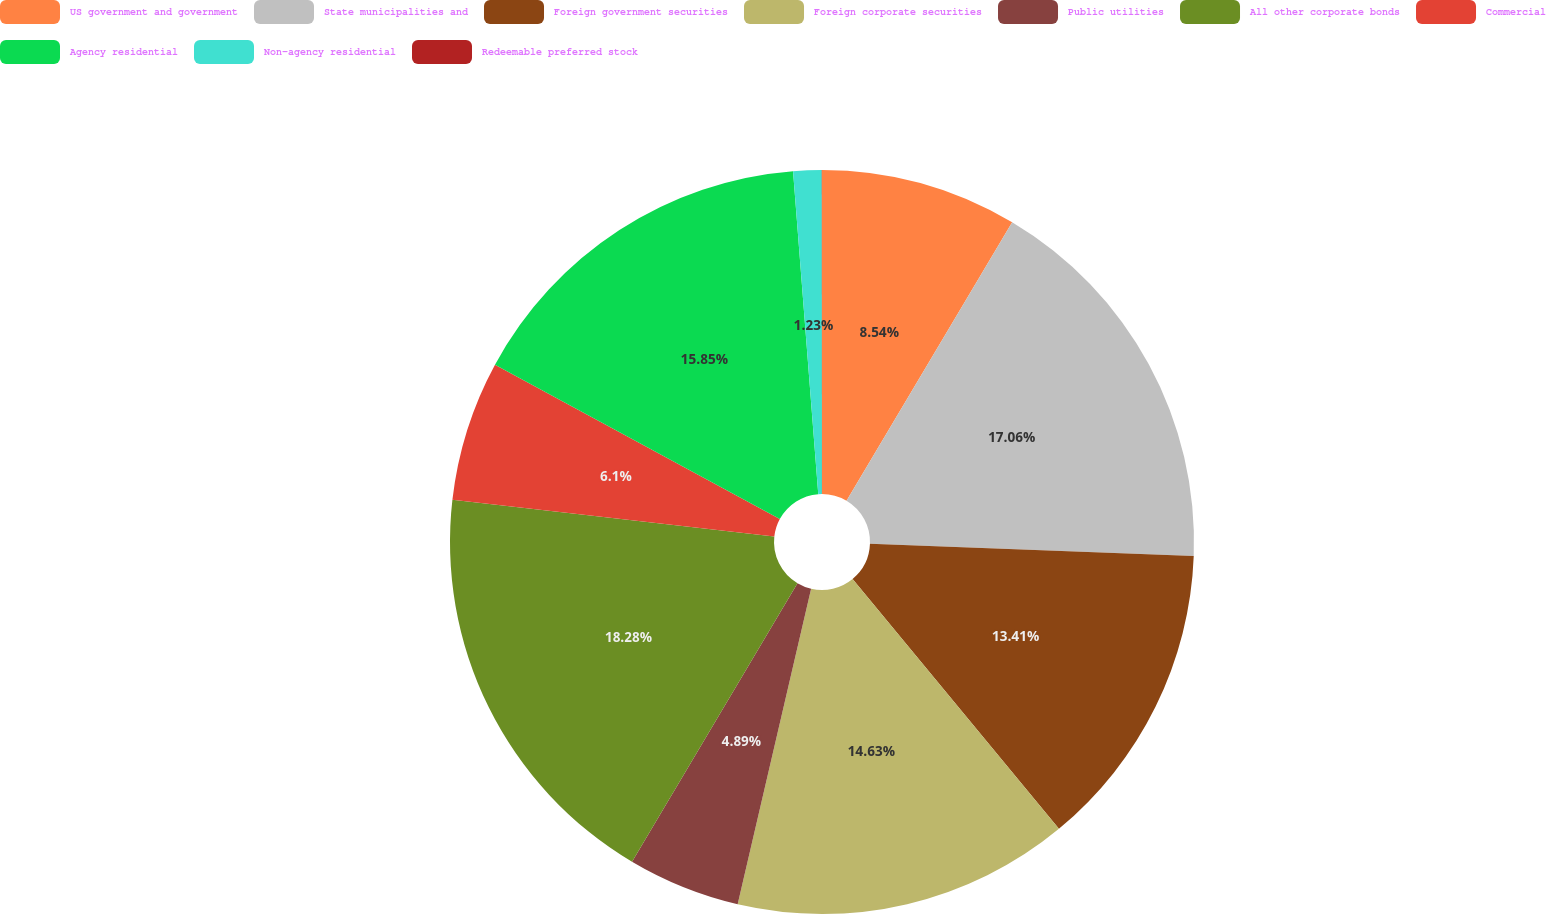Convert chart to OTSL. <chart><loc_0><loc_0><loc_500><loc_500><pie_chart><fcel>US government and government<fcel>State municipalities and<fcel>Foreign government securities<fcel>Foreign corporate securities<fcel>Public utilities<fcel>All other corporate bonds<fcel>Commercial<fcel>Agency residential<fcel>Non-agency residential<fcel>Redeemable preferred stock<nl><fcel>8.54%<fcel>17.06%<fcel>13.41%<fcel>14.63%<fcel>4.89%<fcel>18.28%<fcel>6.1%<fcel>15.85%<fcel>1.23%<fcel>0.01%<nl></chart> 